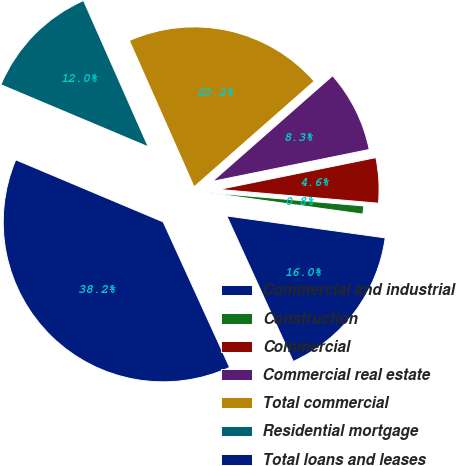Convert chart to OTSL. <chart><loc_0><loc_0><loc_500><loc_500><pie_chart><fcel>Commercial and industrial<fcel>Construction<fcel>Commercial<fcel>Commercial real estate<fcel>Total commercial<fcel>Residential mortgage<fcel>Total loans and leases<nl><fcel>15.99%<fcel>0.82%<fcel>4.56%<fcel>8.29%<fcel>20.15%<fcel>12.02%<fcel>38.16%<nl></chart> 